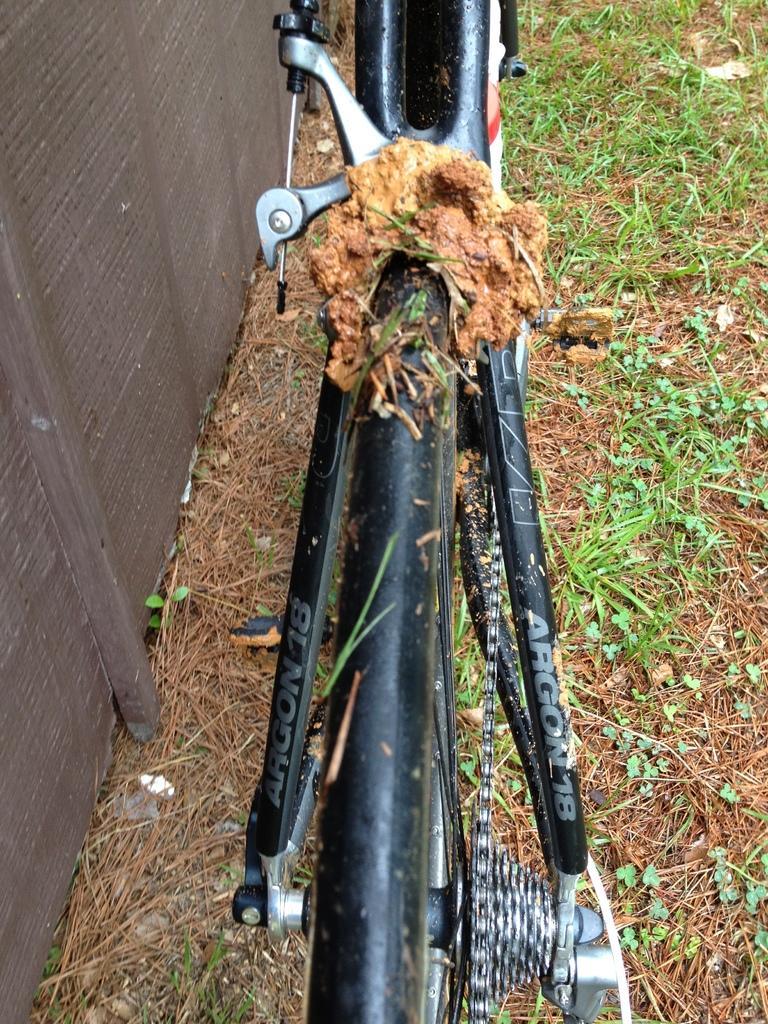Please provide a concise description of this image. In this picture I can observe a bicycle in the middle of the picture. I can observe some grass on the land. 